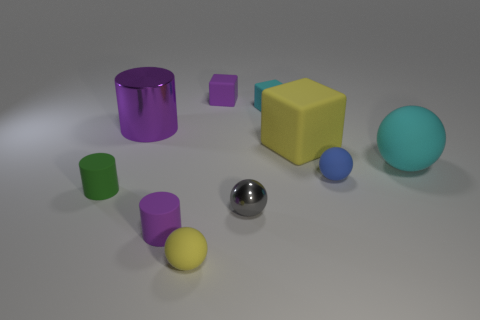Subtract all matte cylinders. How many cylinders are left? 1 Subtract 2 spheres. How many spheres are left? 2 Subtract all blue cubes. Subtract all red balls. How many cubes are left? 3 Subtract all blue cubes. How many purple cylinders are left? 2 Subtract all tiny gray shiny things. Subtract all blue things. How many objects are left? 8 Add 7 purple shiny things. How many purple shiny things are left? 8 Add 8 big gray metallic blocks. How many big gray metallic blocks exist? 8 Subtract all cyan blocks. How many blocks are left? 2 Subtract 0 blue blocks. How many objects are left? 10 Subtract all balls. How many objects are left? 6 